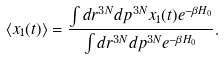<formula> <loc_0><loc_0><loc_500><loc_500>\left < x _ { 1 } ( t ) \right > = \frac { \int d r ^ { 3 N } d p ^ { 3 N } x _ { 1 } ( t ) e ^ { - \beta H _ { 0 } } } { \int d r ^ { 3 N } d p ^ { 3 N } e ^ { - \beta H _ { 0 } } } .</formula> 